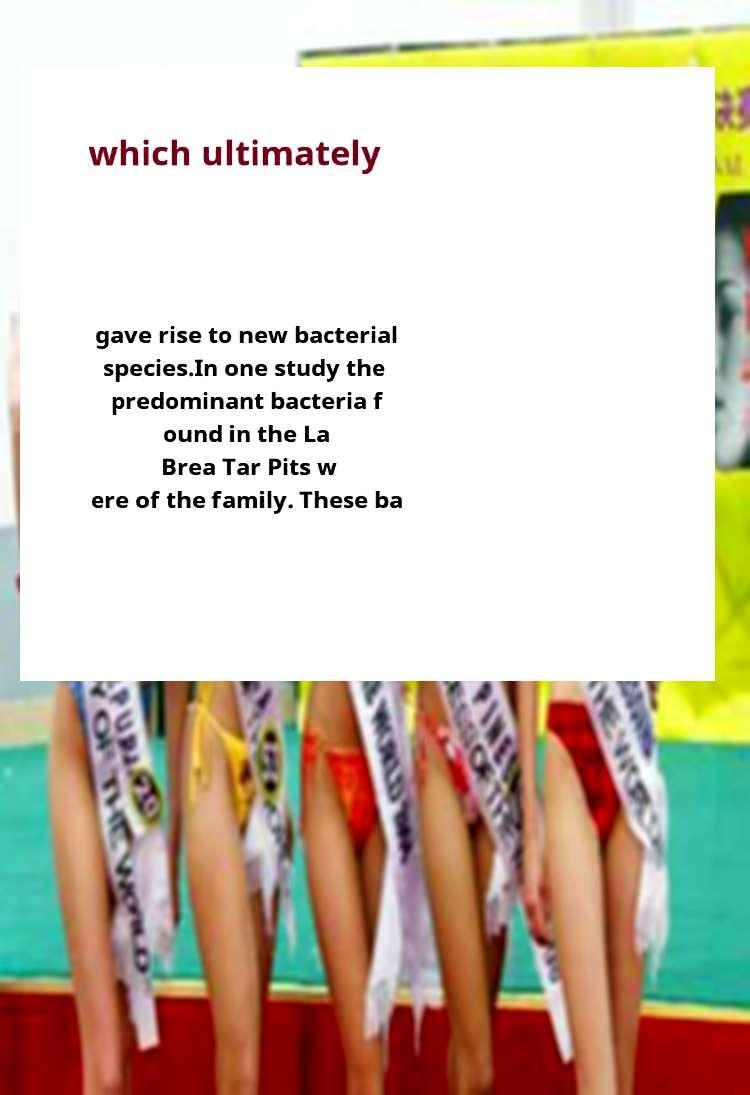There's text embedded in this image that I need extracted. Can you transcribe it verbatim? which ultimately gave rise to new bacterial species.In one study the predominant bacteria f ound in the La Brea Tar Pits w ere of the family. These ba 